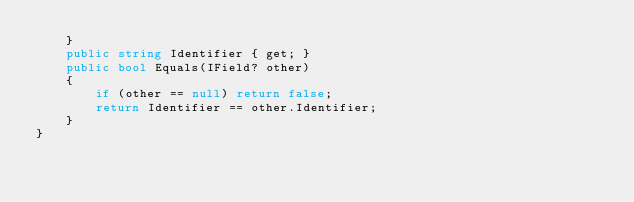<code> <loc_0><loc_0><loc_500><loc_500><_C#_>    }
    public string Identifier { get; }
    public bool Equals(IField? other)
    {
        if (other == null) return false;
        return Identifier == other.Identifier;
    }
}

</code> 